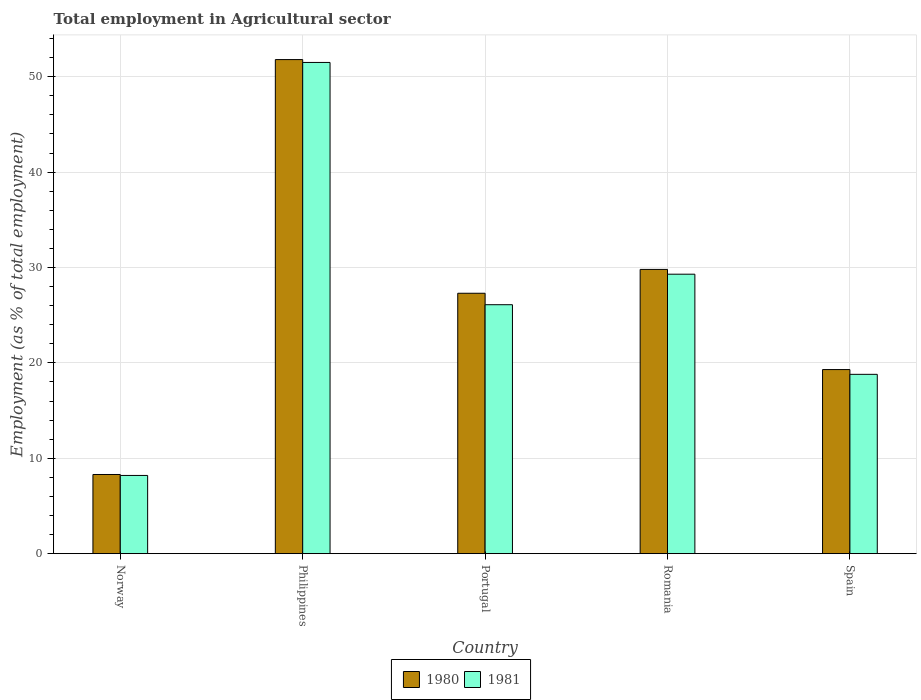Are the number of bars per tick equal to the number of legend labels?
Your answer should be very brief. Yes. What is the label of the 4th group of bars from the left?
Provide a short and direct response. Romania. In how many cases, is the number of bars for a given country not equal to the number of legend labels?
Your answer should be very brief. 0. What is the employment in agricultural sector in 1981 in Portugal?
Make the answer very short. 26.1. Across all countries, what is the maximum employment in agricultural sector in 1980?
Ensure brevity in your answer.  51.8. Across all countries, what is the minimum employment in agricultural sector in 1981?
Provide a succinct answer. 8.2. What is the total employment in agricultural sector in 1980 in the graph?
Give a very brief answer. 136.5. What is the difference between the employment in agricultural sector in 1981 in Norway and that in Spain?
Give a very brief answer. -10.6. What is the difference between the employment in agricultural sector in 1981 in Portugal and the employment in agricultural sector in 1980 in Romania?
Your answer should be compact. -3.7. What is the average employment in agricultural sector in 1981 per country?
Provide a succinct answer. 26.78. What is the difference between the employment in agricultural sector of/in 1981 and employment in agricultural sector of/in 1980 in Philippines?
Your response must be concise. -0.3. In how many countries, is the employment in agricultural sector in 1980 greater than 52 %?
Give a very brief answer. 0. What is the ratio of the employment in agricultural sector in 1981 in Philippines to that in Romania?
Provide a succinct answer. 1.76. Is the employment in agricultural sector in 1981 in Norway less than that in Portugal?
Offer a terse response. Yes. Is the difference between the employment in agricultural sector in 1981 in Philippines and Romania greater than the difference between the employment in agricultural sector in 1980 in Philippines and Romania?
Your answer should be compact. Yes. What is the difference between the highest and the second highest employment in agricultural sector in 1981?
Your response must be concise. -25.4. What is the difference between the highest and the lowest employment in agricultural sector in 1980?
Keep it short and to the point. 43.5. In how many countries, is the employment in agricultural sector in 1980 greater than the average employment in agricultural sector in 1980 taken over all countries?
Offer a very short reply. 2. What does the 2nd bar from the right in Spain represents?
Your answer should be very brief. 1980. Are all the bars in the graph horizontal?
Offer a terse response. No. What is the difference between two consecutive major ticks on the Y-axis?
Your answer should be compact. 10. Are the values on the major ticks of Y-axis written in scientific E-notation?
Keep it short and to the point. No. Does the graph contain grids?
Provide a short and direct response. Yes. How many legend labels are there?
Provide a short and direct response. 2. What is the title of the graph?
Your answer should be compact. Total employment in Agricultural sector. What is the label or title of the X-axis?
Offer a terse response. Country. What is the label or title of the Y-axis?
Offer a very short reply. Employment (as % of total employment). What is the Employment (as % of total employment) in 1980 in Norway?
Your answer should be very brief. 8.3. What is the Employment (as % of total employment) of 1981 in Norway?
Keep it short and to the point. 8.2. What is the Employment (as % of total employment) in 1980 in Philippines?
Ensure brevity in your answer.  51.8. What is the Employment (as % of total employment) of 1981 in Philippines?
Your answer should be compact. 51.5. What is the Employment (as % of total employment) of 1980 in Portugal?
Ensure brevity in your answer.  27.3. What is the Employment (as % of total employment) in 1981 in Portugal?
Your answer should be very brief. 26.1. What is the Employment (as % of total employment) of 1980 in Romania?
Your response must be concise. 29.8. What is the Employment (as % of total employment) in 1981 in Romania?
Keep it short and to the point. 29.3. What is the Employment (as % of total employment) in 1980 in Spain?
Provide a short and direct response. 19.3. What is the Employment (as % of total employment) in 1981 in Spain?
Give a very brief answer. 18.8. Across all countries, what is the maximum Employment (as % of total employment) of 1980?
Ensure brevity in your answer.  51.8. Across all countries, what is the maximum Employment (as % of total employment) of 1981?
Your answer should be very brief. 51.5. Across all countries, what is the minimum Employment (as % of total employment) in 1980?
Give a very brief answer. 8.3. Across all countries, what is the minimum Employment (as % of total employment) in 1981?
Your answer should be very brief. 8.2. What is the total Employment (as % of total employment) of 1980 in the graph?
Offer a terse response. 136.5. What is the total Employment (as % of total employment) in 1981 in the graph?
Ensure brevity in your answer.  133.9. What is the difference between the Employment (as % of total employment) in 1980 in Norway and that in Philippines?
Your answer should be compact. -43.5. What is the difference between the Employment (as % of total employment) of 1981 in Norway and that in Philippines?
Offer a very short reply. -43.3. What is the difference between the Employment (as % of total employment) of 1981 in Norway and that in Portugal?
Your answer should be very brief. -17.9. What is the difference between the Employment (as % of total employment) of 1980 in Norway and that in Romania?
Provide a succinct answer. -21.5. What is the difference between the Employment (as % of total employment) of 1981 in Norway and that in Romania?
Your response must be concise. -21.1. What is the difference between the Employment (as % of total employment) in 1980 in Norway and that in Spain?
Keep it short and to the point. -11. What is the difference between the Employment (as % of total employment) in 1981 in Philippines and that in Portugal?
Make the answer very short. 25.4. What is the difference between the Employment (as % of total employment) in 1980 in Philippines and that in Spain?
Give a very brief answer. 32.5. What is the difference between the Employment (as % of total employment) in 1981 in Philippines and that in Spain?
Keep it short and to the point. 32.7. What is the difference between the Employment (as % of total employment) in 1981 in Portugal and that in Romania?
Your response must be concise. -3.2. What is the difference between the Employment (as % of total employment) of 1980 in Norway and the Employment (as % of total employment) of 1981 in Philippines?
Ensure brevity in your answer.  -43.2. What is the difference between the Employment (as % of total employment) of 1980 in Norway and the Employment (as % of total employment) of 1981 in Portugal?
Offer a terse response. -17.8. What is the difference between the Employment (as % of total employment) of 1980 in Philippines and the Employment (as % of total employment) of 1981 in Portugal?
Your answer should be compact. 25.7. What is the difference between the Employment (as % of total employment) in 1980 in Philippines and the Employment (as % of total employment) in 1981 in Spain?
Keep it short and to the point. 33. What is the difference between the Employment (as % of total employment) of 1980 in Portugal and the Employment (as % of total employment) of 1981 in Romania?
Offer a terse response. -2. What is the difference between the Employment (as % of total employment) of 1980 in Portugal and the Employment (as % of total employment) of 1981 in Spain?
Give a very brief answer. 8.5. What is the difference between the Employment (as % of total employment) in 1980 in Romania and the Employment (as % of total employment) in 1981 in Spain?
Your response must be concise. 11. What is the average Employment (as % of total employment) of 1980 per country?
Your response must be concise. 27.3. What is the average Employment (as % of total employment) in 1981 per country?
Offer a terse response. 26.78. What is the difference between the Employment (as % of total employment) in 1980 and Employment (as % of total employment) in 1981 in Romania?
Make the answer very short. 0.5. What is the difference between the Employment (as % of total employment) of 1980 and Employment (as % of total employment) of 1981 in Spain?
Provide a succinct answer. 0.5. What is the ratio of the Employment (as % of total employment) in 1980 in Norway to that in Philippines?
Your response must be concise. 0.16. What is the ratio of the Employment (as % of total employment) of 1981 in Norway to that in Philippines?
Your answer should be very brief. 0.16. What is the ratio of the Employment (as % of total employment) in 1980 in Norway to that in Portugal?
Offer a terse response. 0.3. What is the ratio of the Employment (as % of total employment) of 1981 in Norway to that in Portugal?
Offer a very short reply. 0.31. What is the ratio of the Employment (as % of total employment) of 1980 in Norway to that in Romania?
Your answer should be compact. 0.28. What is the ratio of the Employment (as % of total employment) of 1981 in Norway to that in Romania?
Offer a terse response. 0.28. What is the ratio of the Employment (as % of total employment) in 1980 in Norway to that in Spain?
Offer a very short reply. 0.43. What is the ratio of the Employment (as % of total employment) in 1981 in Norway to that in Spain?
Give a very brief answer. 0.44. What is the ratio of the Employment (as % of total employment) in 1980 in Philippines to that in Portugal?
Give a very brief answer. 1.9. What is the ratio of the Employment (as % of total employment) of 1981 in Philippines to that in Portugal?
Your response must be concise. 1.97. What is the ratio of the Employment (as % of total employment) of 1980 in Philippines to that in Romania?
Make the answer very short. 1.74. What is the ratio of the Employment (as % of total employment) in 1981 in Philippines to that in Romania?
Keep it short and to the point. 1.76. What is the ratio of the Employment (as % of total employment) of 1980 in Philippines to that in Spain?
Provide a short and direct response. 2.68. What is the ratio of the Employment (as % of total employment) of 1981 in Philippines to that in Spain?
Offer a very short reply. 2.74. What is the ratio of the Employment (as % of total employment) of 1980 in Portugal to that in Romania?
Provide a succinct answer. 0.92. What is the ratio of the Employment (as % of total employment) in 1981 in Portugal to that in Romania?
Keep it short and to the point. 0.89. What is the ratio of the Employment (as % of total employment) in 1980 in Portugal to that in Spain?
Your answer should be compact. 1.41. What is the ratio of the Employment (as % of total employment) in 1981 in Portugal to that in Spain?
Give a very brief answer. 1.39. What is the ratio of the Employment (as % of total employment) in 1980 in Romania to that in Spain?
Offer a terse response. 1.54. What is the ratio of the Employment (as % of total employment) of 1981 in Romania to that in Spain?
Give a very brief answer. 1.56. What is the difference between the highest and the second highest Employment (as % of total employment) of 1980?
Your response must be concise. 22. What is the difference between the highest and the lowest Employment (as % of total employment) of 1980?
Ensure brevity in your answer.  43.5. What is the difference between the highest and the lowest Employment (as % of total employment) in 1981?
Your answer should be compact. 43.3. 